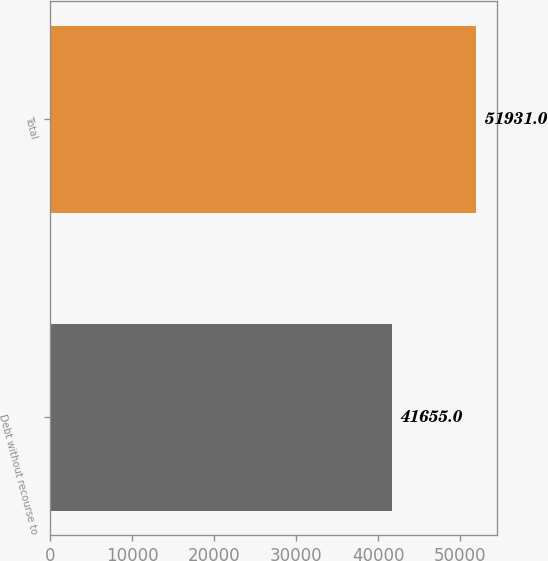<chart> <loc_0><loc_0><loc_500><loc_500><bar_chart><fcel>Debt without recourse to<fcel>Total<nl><fcel>41655<fcel>51931<nl></chart> 